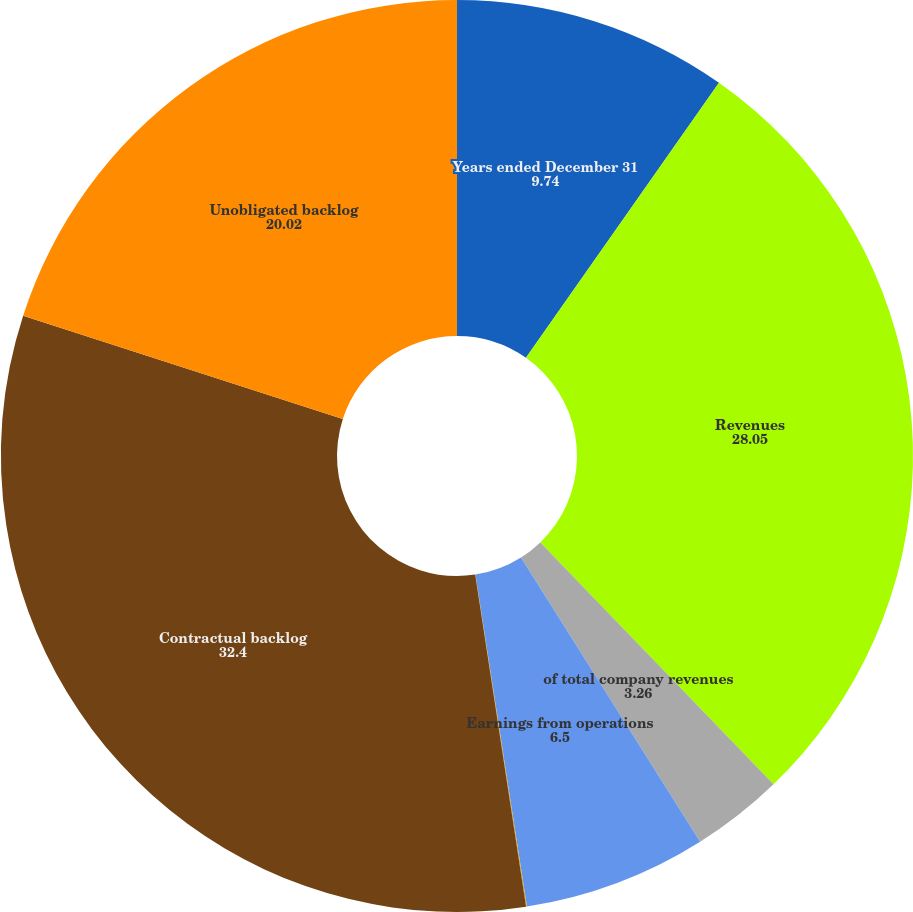Convert chart to OTSL. <chart><loc_0><loc_0><loc_500><loc_500><pie_chart><fcel>Years ended December 31<fcel>Revenues<fcel>of total company revenues<fcel>Earnings from operations<fcel>Operating margins<fcel>Contractual backlog<fcel>Unobligated backlog<nl><fcel>9.74%<fcel>28.05%<fcel>3.26%<fcel>6.5%<fcel>0.03%<fcel>32.4%<fcel>20.02%<nl></chart> 